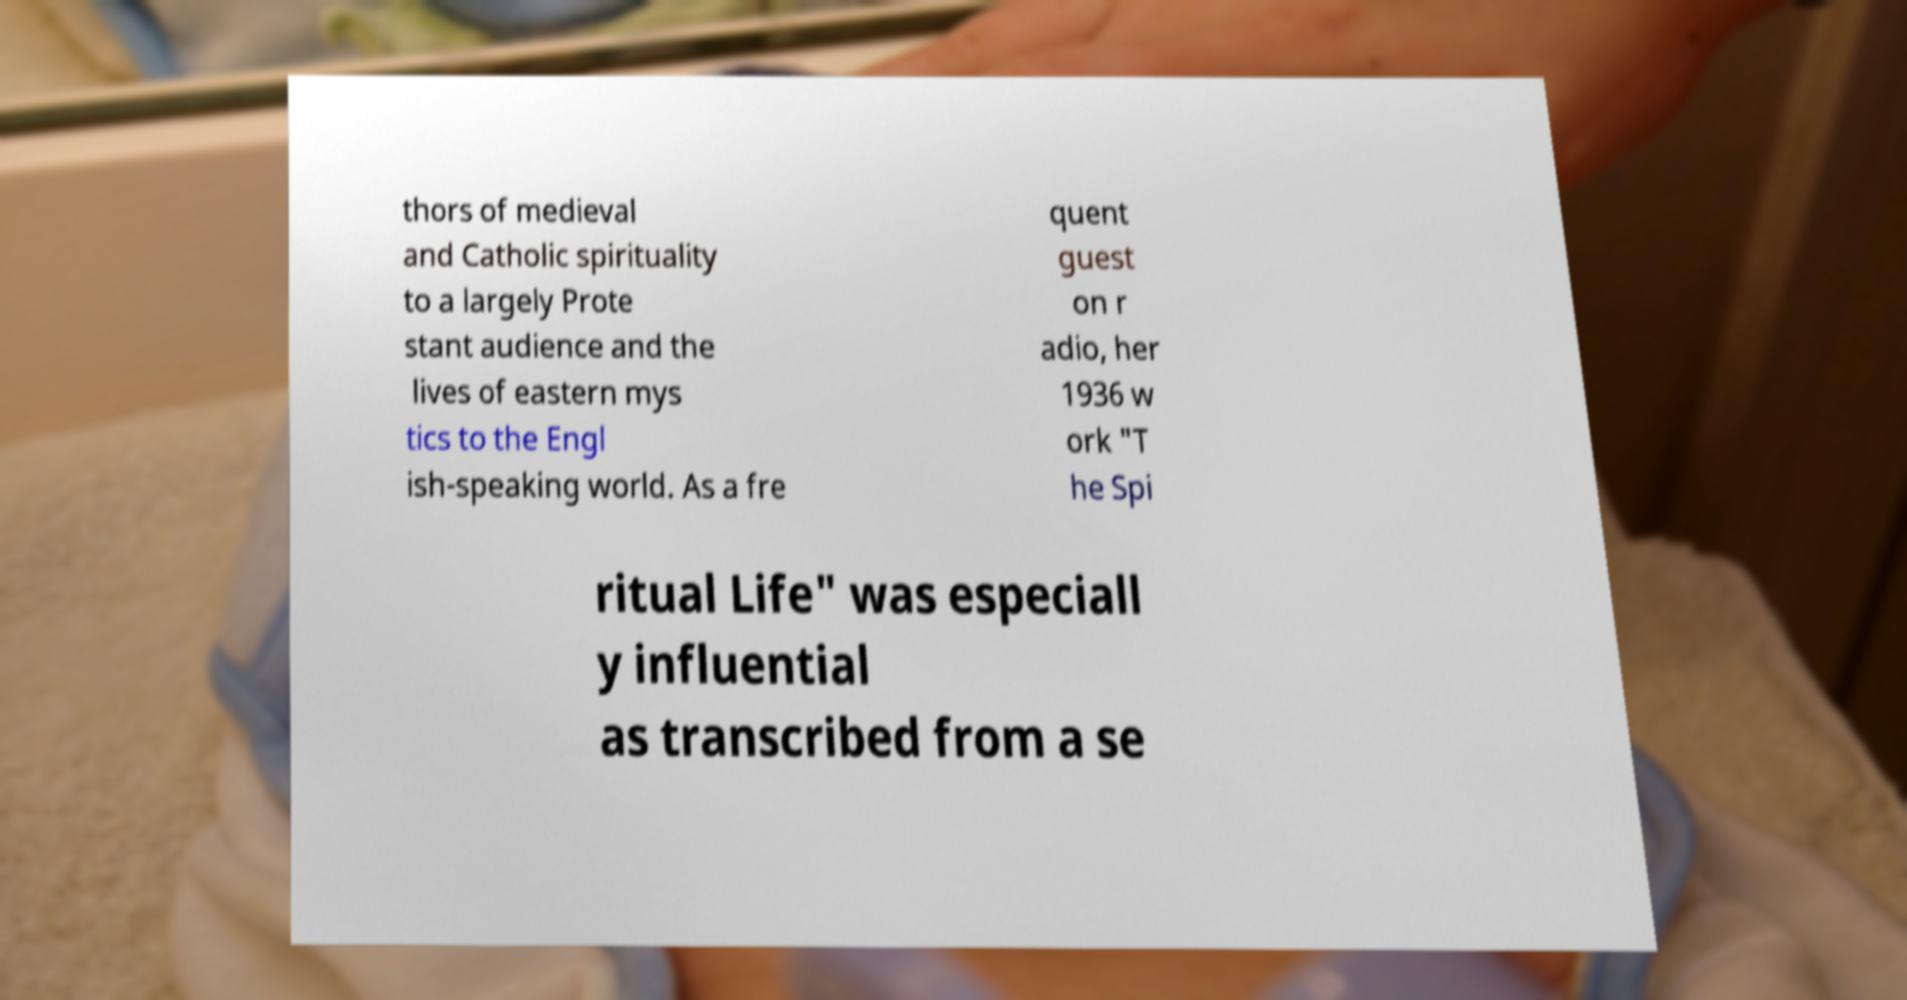What messages or text are displayed in this image? I need them in a readable, typed format. thors of medieval and Catholic spirituality to a largely Prote stant audience and the lives of eastern mys tics to the Engl ish-speaking world. As a fre quent guest on r adio, her 1936 w ork "T he Spi ritual Life" was especiall y influential as transcribed from a se 